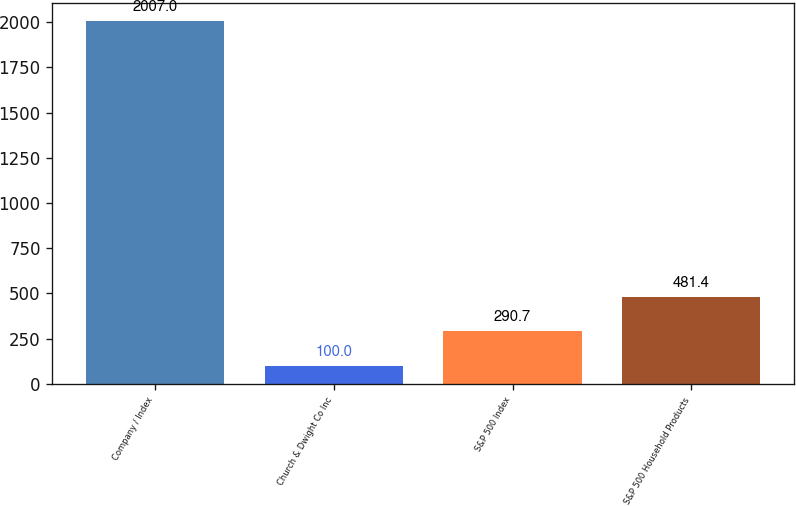Convert chart to OTSL. <chart><loc_0><loc_0><loc_500><loc_500><bar_chart><fcel>Company / Index<fcel>Church & Dwight Co Inc<fcel>S&P 500 Index<fcel>S&P 500 Household Products<nl><fcel>2007<fcel>100<fcel>290.7<fcel>481.4<nl></chart> 